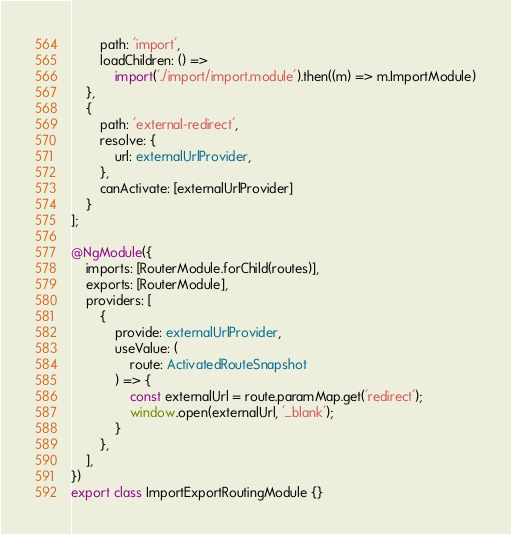Convert code to text. <code><loc_0><loc_0><loc_500><loc_500><_TypeScript_>		path: 'import',
		loadChildren: () =>
			import('./import/import.module').then((m) => m.ImportModule)
	},
	{
		path: 'external-redirect',
		resolve: {
			url: externalUrlProvider,
		},
		canActivate: [externalUrlProvider]
	}
];

@NgModule({
	imports: [RouterModule.forChild(routes)],
	exports: [RouterModule],
	providers: [
        {
            provide: externalUrlProvider,
            useValue: (
				route: ActivatedRouteSnapshot
			) => {
                const externalUrl = route.paramMap.get('redirect');
				window.open(externalUrl, '_blank');
            }
        },
    ],
})
export class ImportExportRoutingModule {}
</code> 